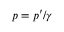Convert formula to latex. <formula><loc_0><loc_0><loc_500><loc_500>p = p ^ { \prime } / \gamma</formula> 